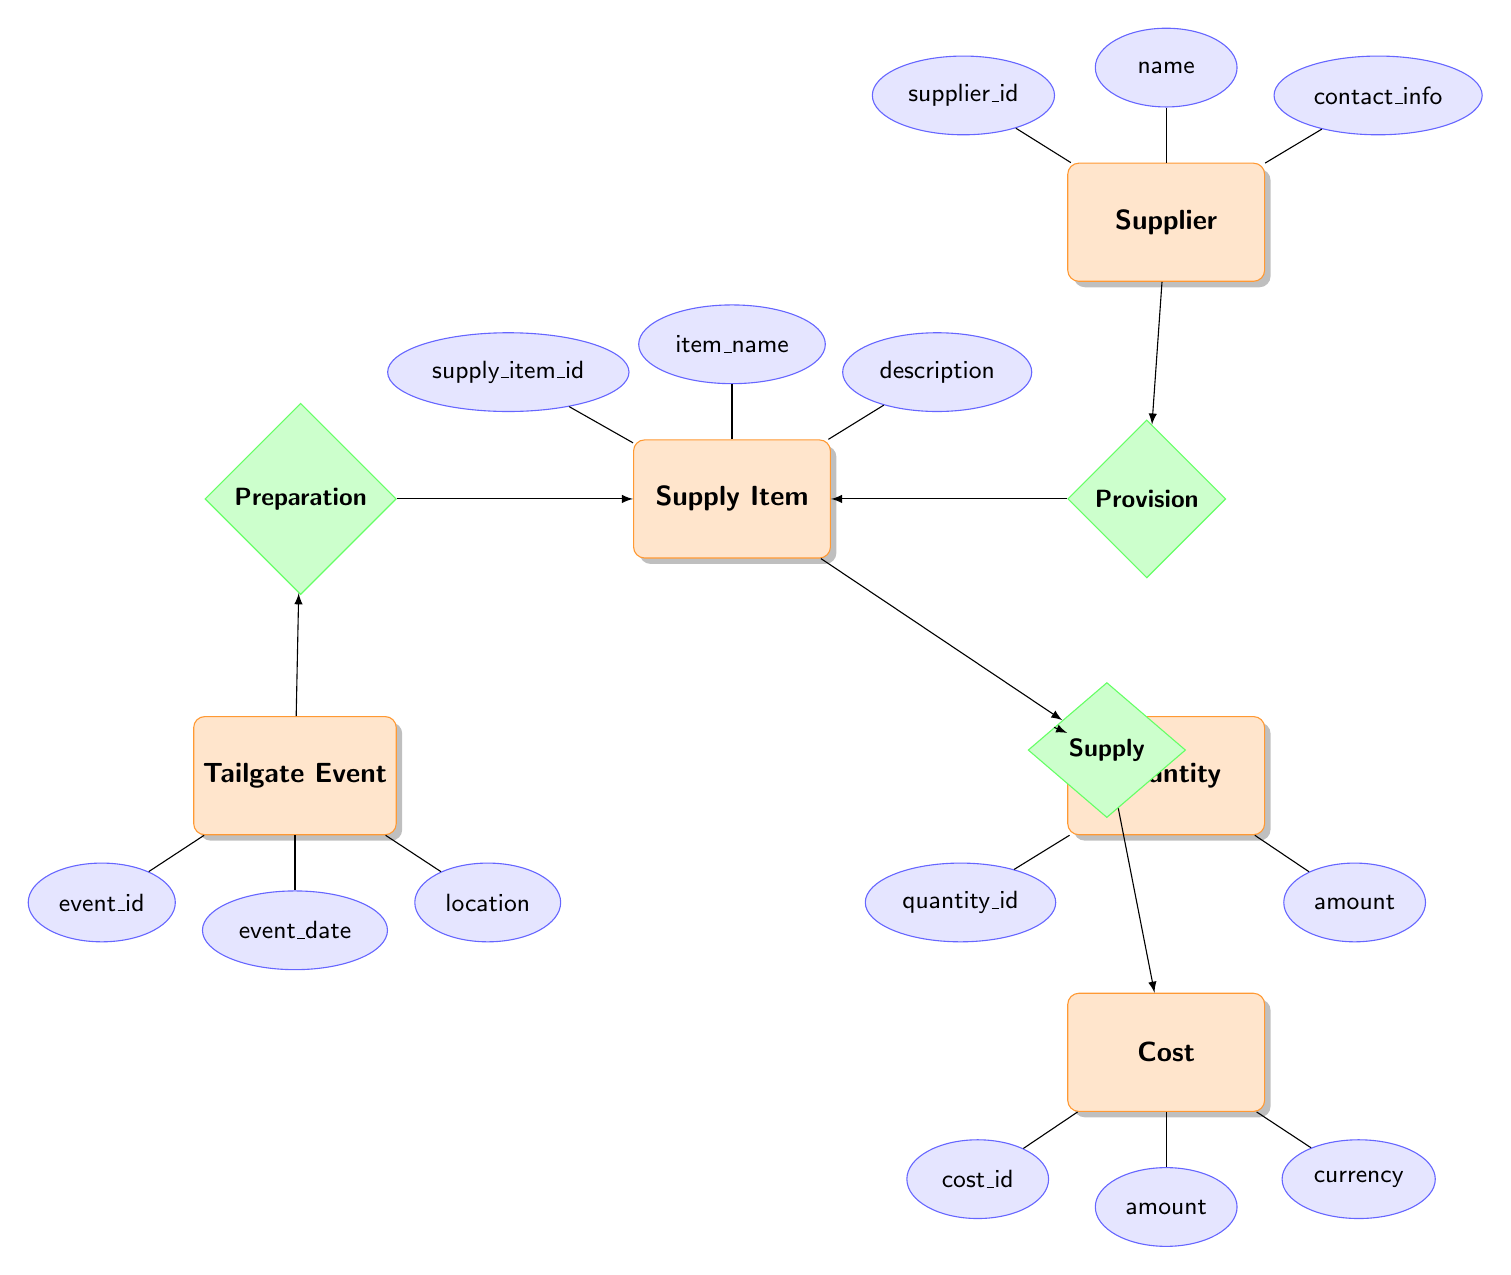What are the entities in the diagram? The entities in the diagram are identified as separate nodes, which include Supply Item, Quantity, Supplier, Cost, and Tailgate Event.
Answer: Supply Item, Quantity, Supplier, Cost, Tailgate Event How many attributes does the Supplier entity have? The Supplier entity has three attributes listed, which are supplier_id, name, and contact_info.
Answer: 3 What is the relationship between Supply Item and Quantity? The relationship between Supply Item and Quantity is established through the Supply relationship. Supply Item produces a supply that includes a certain Quantity.
Answer: Supply What does the Tailgate Event entity represent? The Tailgate Event entity represents an event with attributes related to the event's identification, date, and location where tailgating occurs.
Answer: Event, date, location Which entities relate to the Preparation relationship? The Preparation relationship relates the Tailgate Event entity and the Supply Item entity. It indicates that Supply Items are prepared for a specific Tailgate Event.
Answer: Tailgate Event, Supply Item What is the primary function of the Provision relationship? The primary function of the Provision relationship is to indicate that a Supplier provides Supply Items. This connection emphasizes the role of the Supplier in supplying items.
Answer: Supplier provides Supply Items What are the main attributes of the Quantity entity? The main attributes of the Quantity entity are quantity_id and amount, which represent the identification and specific measurement of the quantity.
Answer: quantity_id, amount How do Cost and Quantity entities connect in the diagram? Cost and Quantity entities connect through the Supply relationship, indicating that a Supply Item has associated cost and quantity details.
Answer: Supply relationship Which entity has a relationship with both Cost and Quantity? The Supply Item entity has a relationship with both Cost and Quantity as it is linked to these entities through the Supply relationship.
Answer: Supply Item What are the attributes of the Cost entity? The Cost entity has three attributes listed, which are cost_id, amount, and currency that detail the monetary aspects associated with Supply Items.
Answer: cost_id, amount, currency 